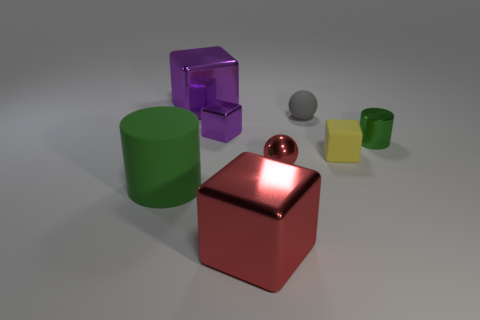What is the size of the thing that is the same color as the small metallic ball?
Give a very brief answer. Large. What shape is the thing that is the same color as the big rubber cylinder?
Make the answer very short. Cylinder. The cylinder on the right side of the purple object behind the sphere that is behind the red metal ball is what color?
Provide a succinct answer. Green. What number of tiny red shiny things are the same shape as the yellow matte thing?
Your answer should be compact. 0. There is a cylinder left of the small yellow block that is behind the red block; what size is it?
Provide a succinct answer. Large. Do the green rubber cylinder and the green shiny cylinder have the same size?
Your response must be concise. No. Is there a tiny gray sphere that is on the left side of the large metal object in front of the green cylinder behind the red sphere?
Give a very brief answer. No. What is the size of the matte cylinder?
Your answer should be very brief. Large. How many metallic objects have the same size as the green matte cylinder?
Your response must be concise. 2. There is a small yellow thing that is the same shape as the large purple thing; what is its material?
Give a very brief answer. Rubber. 